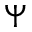Convert formula to latex. <formula><loc_0><loc_0><loc_500><loc_500>\Psi</formula> 